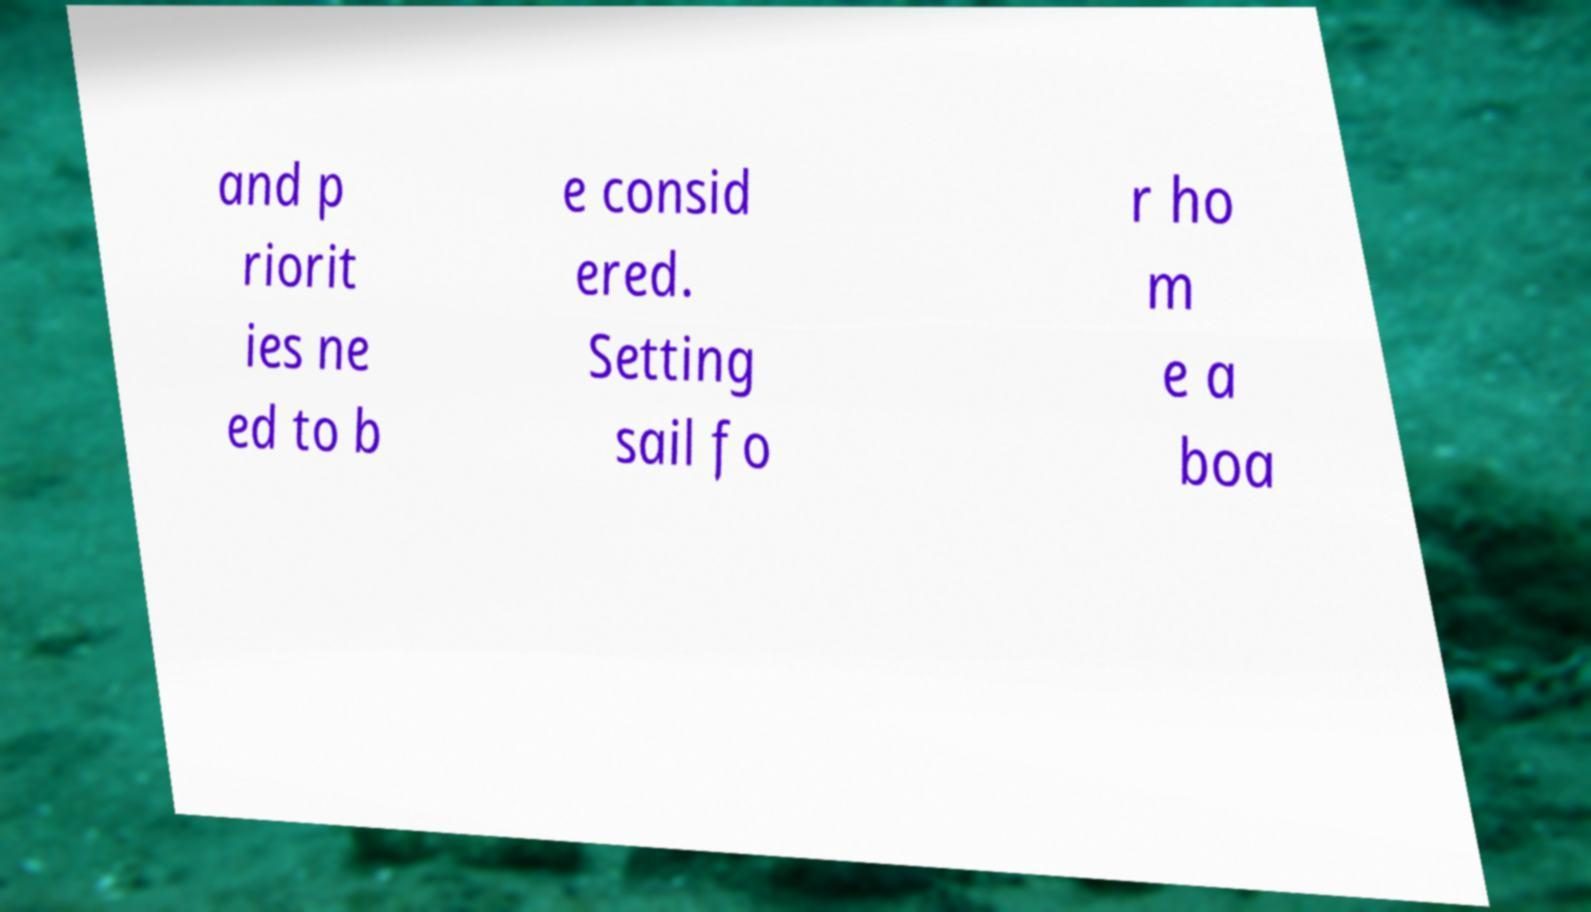Could you assist in decoding the text presented in this image and type it out clearly? and p riorit ies ne ed to b e consid ered. Setting sail fo r ho m e a boa 